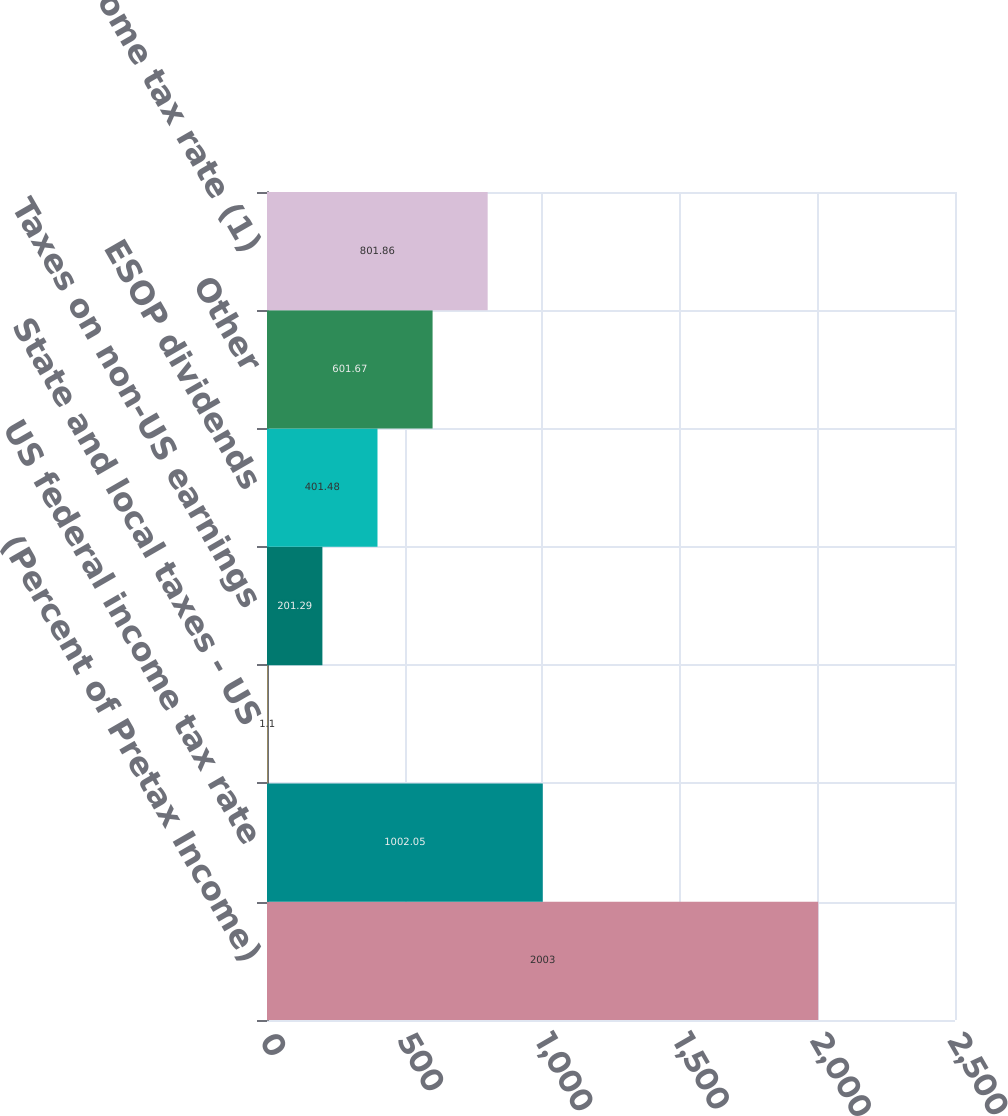<chart> <loc_0><loc_0><loc_500><loc_500><bar_chart><fcel>(Percent of Pretax Income)<fcel>US federal income tax rate<fcel>State and local taxes - US<fcel>Taxes on non-US earnings<fcel>ESOP dividends<fcel>Other<fcel>Effective income tax rate (1)<nl><fcel>2003<fcel>1002.05<fcel>1.1<fcel>201.29<fcel>401.48<fcel>601.67<fcel>801.86<nl></chart> 